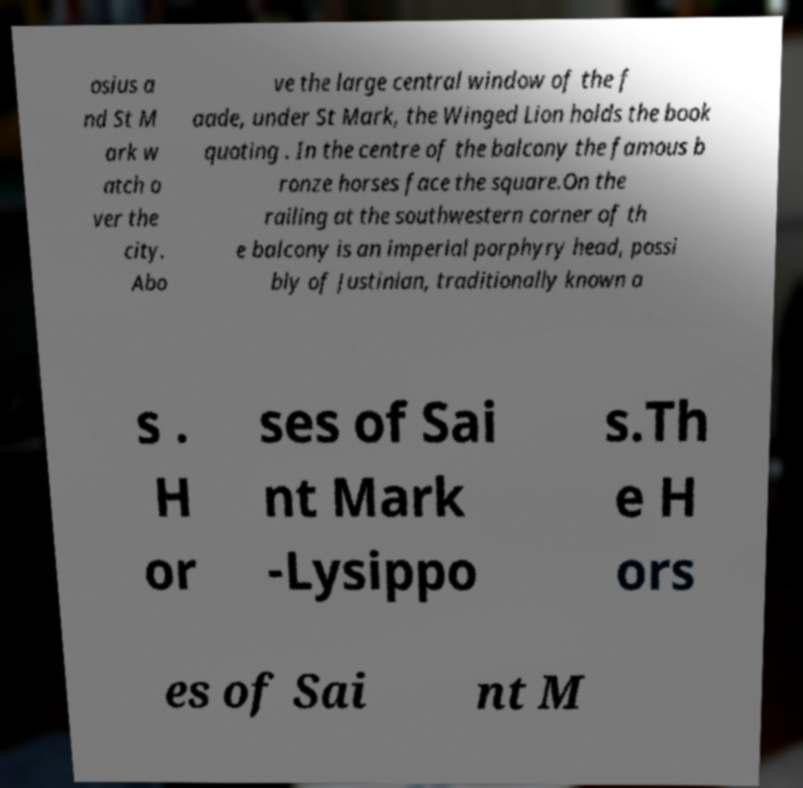Can you accurately transcribe the text from the provided image for me? osius a nd St M ark w atch o ver the city. Abo ve the large central window of the f aade, under St Mark, the Winged Lion holds the book quoting . In the centre of the balcony the famous b ronze horses face the square.On the railing at the southwestern corner of th e balcony is an imperial porphyry head, possi bly of Justinian, traditionally known a s . H or ses of Sai nt Mark -Lysippo s.Th e H ors es of Sai nt M 